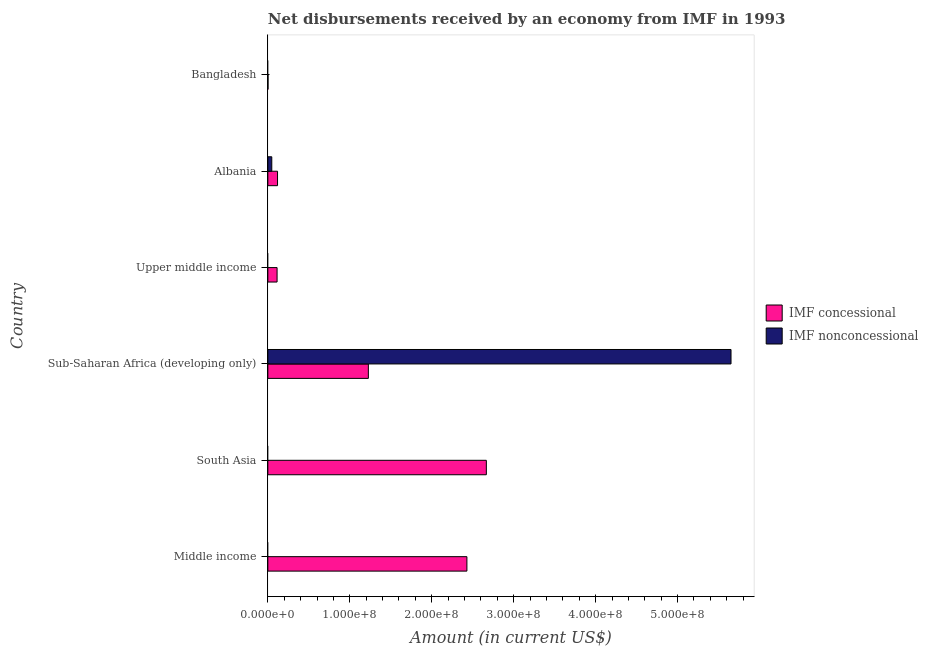Are the number of bars on each tick of the Y-axis equal?
Your answer should be compact. No. How many bars are there on the 6th tick from the top?
Provide a succinct answer. 1. How many bars are there on the 2nd tick from the bottom?
Provide a short and direct response. 1. In how many cases, is the number of bars for a given country not equal to the number of legend labels?
Provide a succinct answer. 4. Across all countries, what is the maximum net concessional disbursements from imf?
Offer a very short reply. 2.67e+08. In which country was the net concessional disbursements from imf maximum?
Provide a short and direct response. South Asia. What is the total net non concessional disbursements from imf in the graph?
Your answer should be compact. 5.70e+08. What is the difference between the net concessional disbursements from imf in Sub-Saharan Africa (developing only) and that in Upper middle income?
Provide a succinct answer. 1.11e+08. What is the difference between the net non concessional disbursements from imf in Albania and the net concessional disbursements from imf in Sub-Saharan Africa (developing only)?
Keep it short and to the point. -1.18e+08. What is the average net non concessional disbursements from imf per country?
Offer a terse response. 9.50e+07. What is the difference between the net concessional disbursements from imf and net non concessional disbursements from imf in Albania?
Offer a very short reply. 7.03e+06. In how many countries, is the net non concessional disbursements from imf greater than 460000000 US$?
Your answer should be compact. 1. What is the ratio of the net concessional disbursements from imf in Albania to that in Middle income?
Give a very brief answer. 0.05. Is the difference between the net concessional disbursements from imf in Albania and Sub-Saharan Africa (developing only) greater than the difference between the net non concessional disbursements from imf in Albania and Sub-Saharan Africa (developing only)?
Keep it short and to the point. Yes. What is the difference between the highest and the second highest net concessional disbursements from imf?
Make the answer very short. 2.37e+07. What is the difference between the highest and the lowest net non concessional disbursements from imf?
Your answer should be compact. 5.65e+08. Is the sum of the net concessional disbursements from imf in South Asia and Sub-Saharan Africa (developing only) greater than the maximum net non concessional disbursements from imf across all countries?
Keep it short and to the point. No. Are all the bars in the graph horizontal?
Offer a very short reply. Yes. How many countries are there in the graph?
Ensure brevity in your answer.  6. Are the values on the major ticks of X-axis written in scientific E-notation?
Make the answer very short. Yes. Does the graph contain any zero values?
Offer a terse response. Yes. What is the title of the graph?
Offer a terse response. Net disbursements received by an economy from IMF in 1993. Does "Foreign liabilities" appear as one of the legend labels in the graph?
Keep it short and to the point. No. What is the label or title of the Y-axis?
Your answer should be very brief. Country. What is the Amount (in current US$) in IMF concessional in Middle income?
Your answer should be very brief. 2.43e+08. What is the Amount (in current US$) in IMF concessional in South Asia?
Your answer should be compact. 2.67e+08. What is the Amount (in current US$) in IMF nonconcessional in South Asia?
Your answer should be very brief. 0. What is the Amount (in current US$) in IMF concessional in Sub-Saharan Africa (developing only)?
Your response must be concise. 1.23e+08. What is the Amount (in current US$) in IMF nonconcessional in Sub-Saharan Africa (developing only)?
Your response must be concise. 5.65e+08. What is the Amount (in current US$) of IMF concessional in Upper middle income?
Give a very brief answer. 1.13e+07. What is the Amount (in current US$) of IMF concessional in Albania?
Your response must be concise. 1.18e+07. What is the Amount (in current US$) of IMF nonconcessional in Albania?
Provide a succinct answer. 4.80e+06. What is the Amount (in current US$) of IMF concessional in Bangladesh?
Your response must be concise. 2.14e+05. Across all countries, what is the maximum Amount (in current US$) in IMF concessional?
Keep it short and to the point. 2.67e+08. Across all countries, what is the maximum Amount (in current US$) of IMF nonconcessional?
Provide a short and direct response. 5.65e+08. Across all countries, what is the minimum Amount (in current US$) of IMF concessional?
Keep it short and to the point. 2.14e+05. Across all countries, what is the minimum Amount (in current US$) in IMF nonconcessional?
Make the answer very short. 0. What is the total Amount (in current US$) in IMF concessional in the graph?
Your answer should be very brief. 6.56e+08. What is the total Amount (in current US$) of IMF nonconcessional in the graph?
Ensure brevity in your answer.  5.70e+08. What is the difference between the Amount (in current US$) of IMF concessional in Middle income and that in South Asia?
Your answer should be very brief. -2.37e+07. What is the difference between the Amount (in current US$) in IMF concessional in Middle income and that in Sub-Saharan Africa (developing only)?
Your answer should be very brief. 1.20e+08. What is the difference between the Amount (in current US$) in IMF concessional in Middle income and that in Upper middle income?
Your answer should be compact. 2.32e+08. What is the difference between the Amount (in current US$) of IMF concessional in Middle income and that in Albania?
Offer a very short reply. 2.31e+08. What is the difference between the Amount (in current US$) of IMF concessional in Middle income and that in Bangladesh?
Your answer should be very brief. 2.43e+08. What is the difference between the Amount (in current US$) of IMF concessional in South Asia and that in Sub-Saharan Africa (developing only)?
Your response must be concise. 1.44e+08. What is the difference between the Amount (in current US$) of IMF concessional in South Asia and that in Upper middle income?
Your answer should be very brief. 2.55e+08. What is the difference between the Amount (in current US$) in IMF concessional in South Asia and that in Albania?
Ensure brevity in your answer.  2.55e+08. What is the difference between the Amount (in current US$) of IMF concessional in South Asia and that in Bangladesh?
Provide a short and direct response. 2.66e+08. What is the difference between the Amount (in current US$) in IMF concessional in Sub-Saharan Africa (developing only) and that in Upper middle income?
Make the answer very short. 1.11e+08. What is the difference between the Amount (in current US$) of IMF concessional in Sub-Saharan Africa (developing only) and that in Albania?
Your answer should be compact. 1.11e+08. What is the difference between the Amount (in current US$) of IMF nonconcessional in Sub-Saharan Africa (developing only) and that in Albania?
Make the answer very short. 5.60e+08. What is the difference between the Amount (in current US$) of IMF concessional in Sub-Saharan Africa (developing only) and that in Bangladesh?
Offer a very short reply. 1.22e+08. What is the difference between the Amount (in current US$) in IMF concessional in Upper middle income and that in Albania?
Provide a short and direct response. -5.59e+05. What is the difference between the Amount (in current US$) of IMF concessional in Upper middle income and that in Bangladesh?
Your response must be concise. 1.11e+07. What is the difference between the Amount (in current US$) in IMF concessional in Albania and that in Bangladesh?
Offer a terse response. 1.16e+07. What is the difference between the Amount (in current US$) of IMF concessional in Middle income and the Amount (in current US$) of IMF nonconcessional in Sub-Saharan Africa (developing only)?
Offer a very short reply. -3.22e+08. What is the difference between the Amount (in current US$) in IMF concessional in Middle income and the Amount (in current US$) in IMF nonconcessional in Albania?
Your answer should be very brief. 2.38e+08. What is the difference between the Amount (in current US$) of IMF concessional in South Asia and the Amount (in current US$) of IMF nonconcessional in Sub-Saharan Africa (developing only)?
Ensure brevity in your answer.  -2.99e+08. What is the difference between the Amount (in current US$) of IMF concessional in South Asia and the Amount (in current US$) of IMF nonconcessional in Albania?
Your answer should be very brief. 2.62e+08. What is the difference between the Amount (in current US$) in IMF concessional in Sub-Saharan Africa (developing only) and the Amount (in current US$) in IMF nonconcessional in Albania?
Ensure brevity in your answer.  1.18e+08. What is the difference between the Amount (in current US$) in IMF concessional in Upper middle income and the Amount (in current US$) in IMF nonconcessional in Albania?
Give a very brief answer. 6.47e+06. What is the average Amount (in current US$) of IMF concessional per country?
Offer a very short reply. 1.09e+08. What is the average Amount (in current US$) in IMF nonconcessional per country?
Offer a terse response. 9.50e+07. What is the difference between the Amount (in current US$) of IMF concessional and Amount (in current US$) of IMF nonconcessional in Sub-Saharan Africa (developing only)?
Provide a succinct answer. -4.43e+08. What is the difference between the Amount (in current US$) in IMF concessional and Amount (in current US$) in IMF nonconcessional in Albania?
Provide a short and direct response. 7.03e+06. What is the ratio of the Amount (in current US$) in IMF concessional in Middle income to that in South Asia?
Ensure brevity in your answer.  0.91. What is the ratio of the Amount (in current US$) in IMF concessional in Middle income to that in Sub-Saharan Africa (developing only)?
Give a very brief answer. 1.98. What is the ratio of the Amount (in current US$) of IMF concessional in Middle income to that in Upper middle income?
Offer a very short reply. 21.56. What is the ratio of the Amount (in current US$) in IMF concessional in Middle income to that in Albania?
Your answer should be compact. 20.54. What is the ratio of the Amount (in current US$) of IMF concessional in Middle income to that in Bangladesh?
Keep it short and to the point. 1135.19. What is the ratio of the Amount (in current US$) in IMF concessional in South Asia to that in Sub-Saharan Africa (developing only)?
Offer a very short reply. 2.17. What is the ratio of the Amount (in current US$) in IMF concessional in South Asia to that in Upper middle income?
Your answer should be compact. 23.66. What is the ratio of the Amount (in current US$) of IMF concessional in South Asia to that in Albania?
Provide a short and direct response. 22.55. What is the ratio of the Amount (in current US$) of IMF concessional in South Asia to that in Bangladesh?
Your answer should be very brief. 1246.06. What is the ratio of the Amount (in current US$) of IMF concessional in Sub-Saharan Africa (developing only) to that in Upper middle income?
Provide a short and direct response. 10.89. What is the ratio of the Amount (in current US$) in IMF concessional in Sub-Saharan Africa (developing only) to that in Albania?
Offer a very short reply. 10.37. What is the ratio of the Amount (in current US$) of IMF nonconcessional in Sub-Saharan Africa (developing only) to that in Albania?
Keep it short and to the point. 117.74. What is the ratio of the Amount (in current US$) of IMF concessional in Sub-Saharan Africa (developing only) to that in Bangladesh?
Offer a terse response. 573.24. What is the ratio of the Amount (in current US$) in IMF concessional in Upper middle income to that in Albania?
Make the answer very short. 0.95. What is the ratio of the Amount (in current US$) in IMF concessional in Upper middle income to that in Bangladesh?
Offer a terse response. 52.65. What is the ratio of the Amount (in current US$) of IMF concessional in Albania to that in Bangladesh?
Your answer should be compact. 55.27. What is the difference between the highest and the second highest Amount (in current US$) in IMF concessional?
Provide a short and direct response. 2.37e+07. What is the difference between the highest and the lowest Amount (in current US$) of IMF concessional?
Ensure brevity in your answer.  2.66e+08. What is the difference between the highest and the lowest Amount (in current US$) of IMF nonconcessional?
Keep it short and to the point. 5.65e+08. 